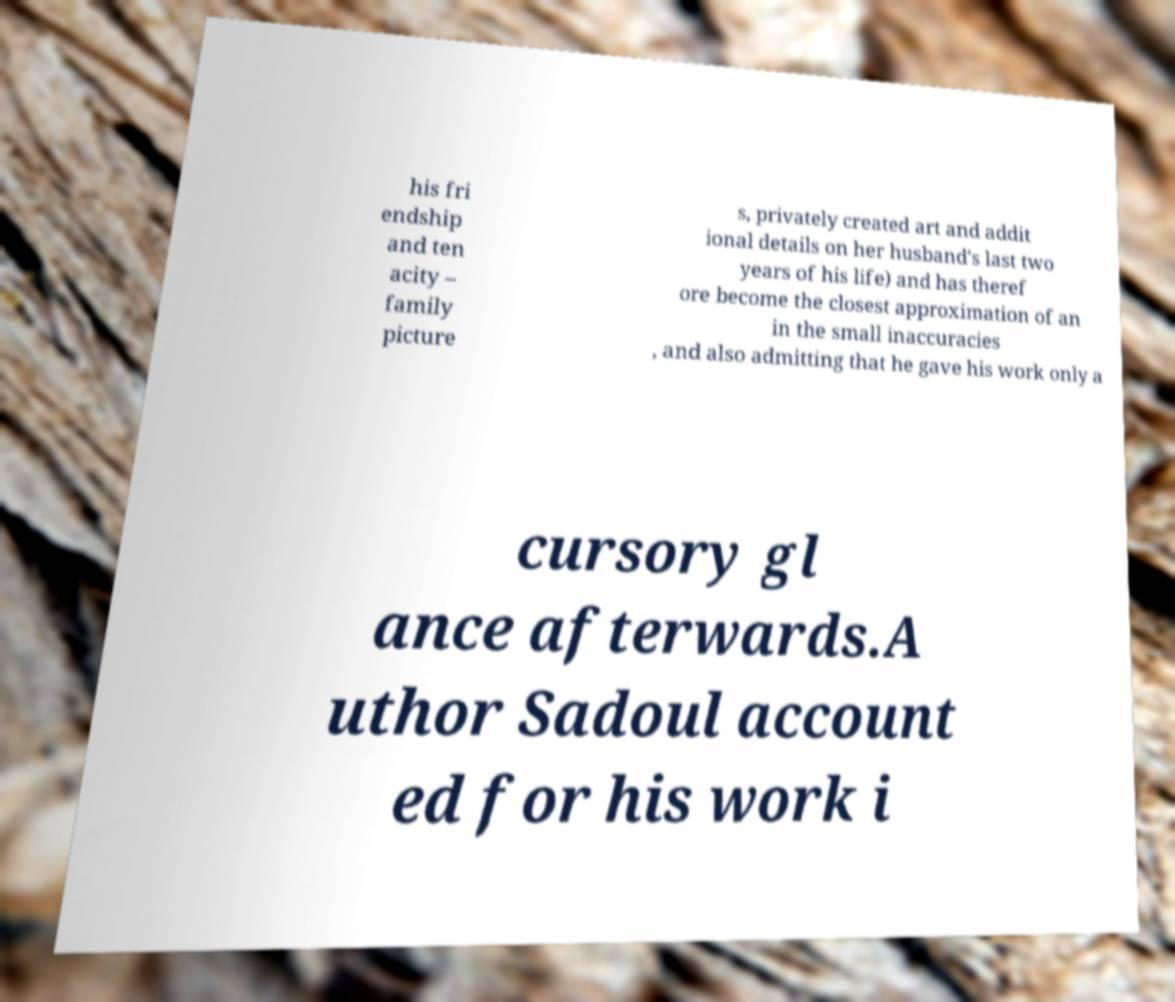Can you accurately transcribe the text from the provided image for me? his fri endship and ten acity – family picture s, privately created art and addit ional details on her husband's last two years of his life) and has theref ore become the closest approximation of an in the small inaccuracies , and also admitting that he gave his work only a cursory gl ance afterwards.A uthor Sadoul account ed for his work i 